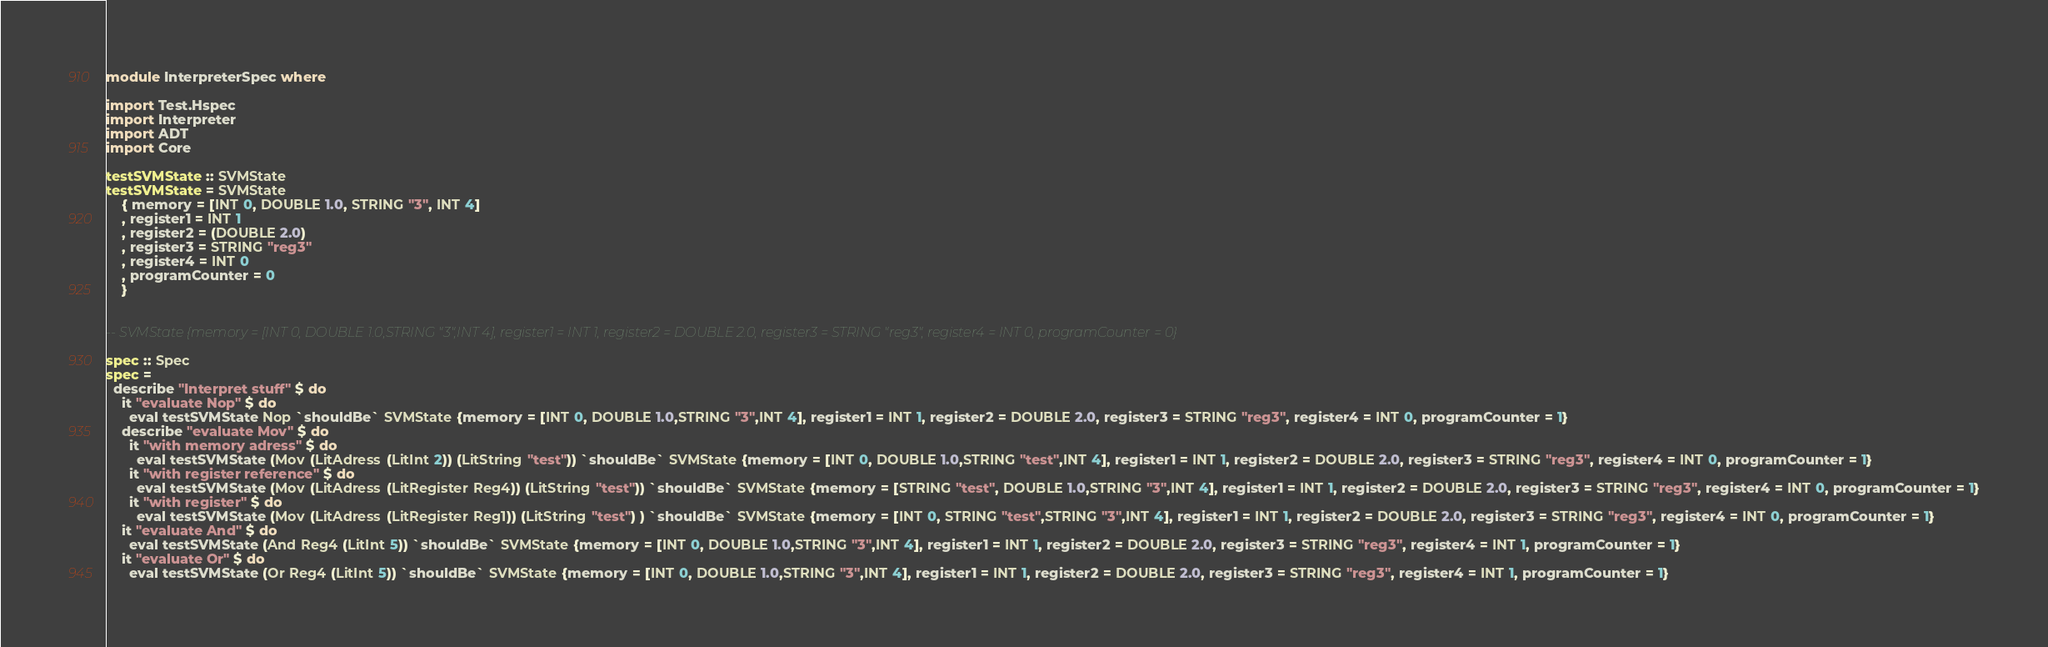Convert code to text. <code><loc_0><loc_0><loc_500><loc_500><_Haskell_>module InterpreterSpec where

import Test.Hspec
import Interpreter
import ADT
import Core

testSVMState :: SVMState
testSVMState = SVMState
    { memory = [INT 0, DOUBLE 1.0, STRING "3", INT 4]
    , register1 = INT 1
    , register2 = (DOUBLE 2.0)
    , register3 = STRING "reg3"
    , register4 = INT 0
    , programCounter = 0
    } 


-- SVMState {memory = [INT 0, DOUBLE 1.0,STRING "3",INT 4], register1 = INT 1, register2 = DOUBLE 2.0, register3 = STRING "reg3", register4 = INT 0, programCounter = 0}

spec :: Spec
spec = 
  describe "Interpret stuff" $ do
    it "evaluate Nop" $ do
      eval testSVMState Nop `shouldBe` SVMState {memory = [INT 0, DOUBLE 1.0,STRING "3",INT 4], register1 = INT 1, register2 = DOUBLE 2.0, register3 = STRING "reg3", register4 = INT 0, programCounter = 1}
    describe "evaluate Mov" $ do
      it "with memory adress" $ do
        eval testSVMState (Mov (LitAdress (LitInt 2)) (LitString "test")) `shouldBe` SVMState {memory = [INT 0, DOUBLE 1.0,STRING "test",INT 4], register1 = INT 1, register2 = DOUBLE 2.0, register3 = STRING "reg3", register4 = INT 0, programCounter = 1}
      it "with register reference" $ do
        eval testSVMState (Mov (LitAdress (LitRegister Reg4)) (LitString "test")) `shouldBe` SVMState {memory = [STRING "test", DOUBLE 1.0,STRING "3",INT 4], register1 = INT 1, register2 = DOUBLE 2.0, register3 = STRING "reg3", register4 = INT 0, programCounter = 1}
      it "with register" $ do
        eval testSVMState (Mov (LitAdress (LitRegister Reg1)) (LitString "test") ) `shouldBe` SVMState {memory = [INT 0, STRING "test",STRING "3",INT 4], register1 = INT 1, register2 = DOUBLE 2.0, register3 = STRING "reg3", register4 = INT 0, programCounter = 1}
    it "evaluate And" $ do
      eval testSVMState (And Reg4 (LitInt 5)) `shouldBe` SVMState {memory = [INT 0, DOUBLE 1.0,STRING "3",INT 4], register1 = INT 1, register2 = DOUBLE 2.0, register3 = STRING "reg3", register4 = INT 1, programCounter = 1}
    it "evaluate Or" $ do
      eval testSVMState (Or Reg4 (LitInt 5)) `shouldBe` SVMState {memory = [INT 0, DOUBLE 1.0,STRING "3",INT 4], register1 = INT 1, register2 = DOUBLE 2.0, register3 = STRING "reg3", register4 = INT 1, programCounter = 1}</code> 